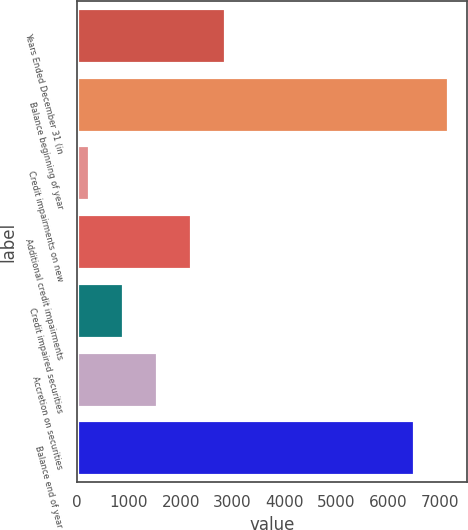Convert chart. <chart><loc_0><loc_0><loc_500><loc_500><bar_chart><fcel>Years Ended December 31 (in<fcel>Balance beginning of year<fcel>Credit impairments on new<fcel>Additional credit impairments<fcel>Credit impaired securities<fcel>Accretion on securities<fcel>Balance end of year<nl><fcel>2855.4<fcel>7159.1<fcel>235<fcel>2200.3<fcel>890.1<fcel>1545.2<fcel>6504<nl></chart> 